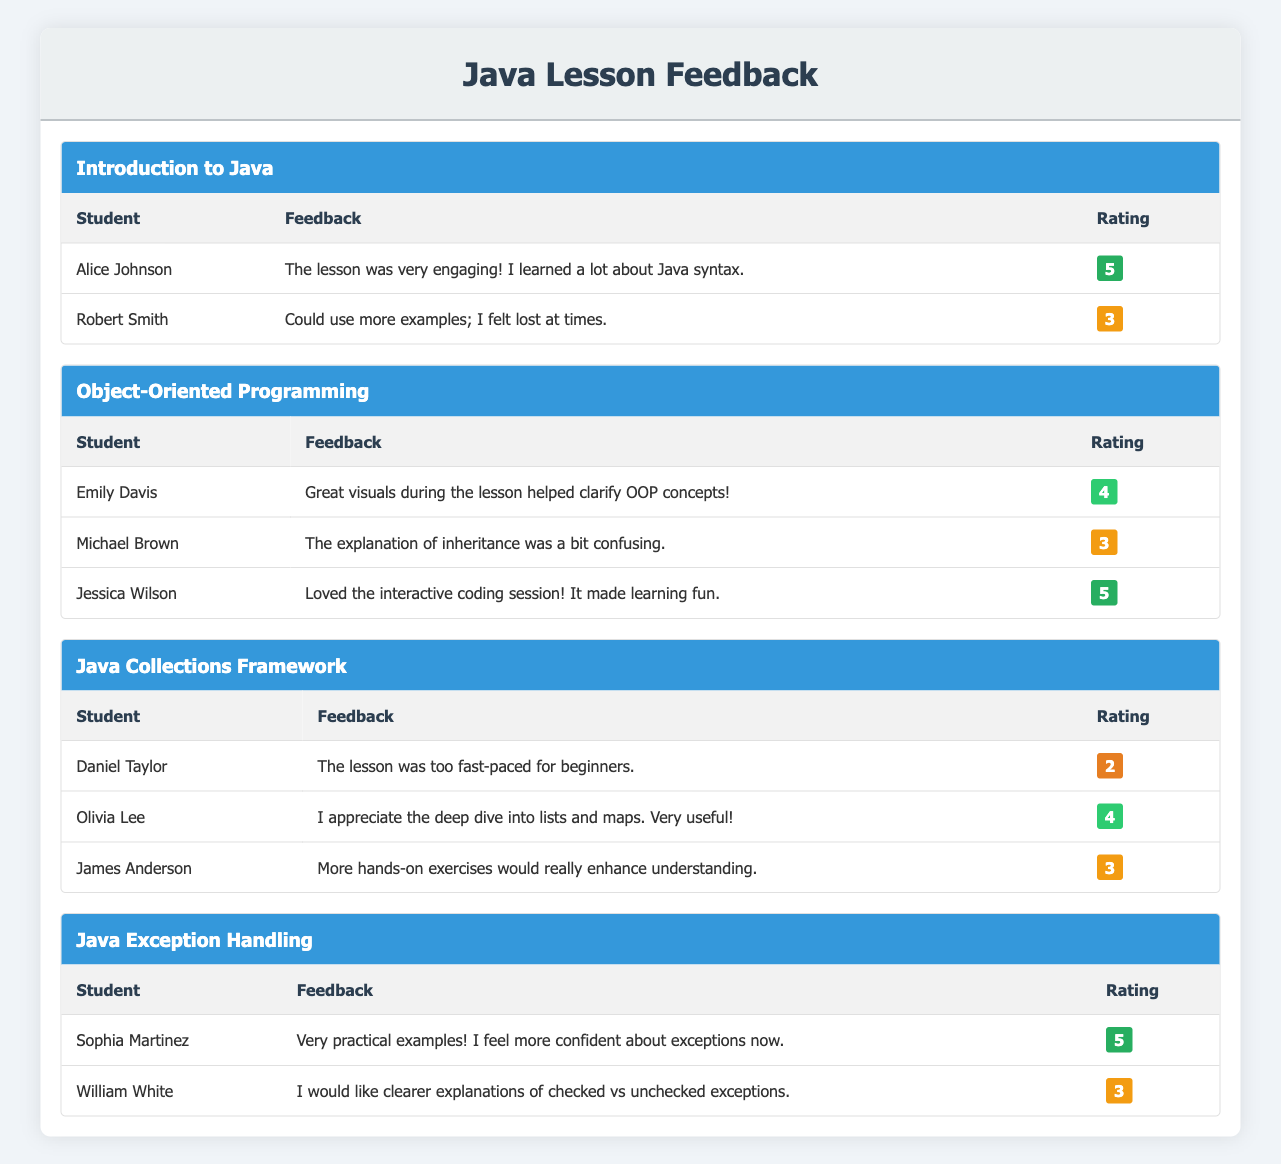What was the highest rating given for the "Java Collections Framework"? The feedback ratings for the "Java Collections Framework" lesson are 2, 4, and 3. The highest rating among these is 4, given by Olivia Lee.
Answer: 4 What feedback did Alice Johnson provide for the "Introduction to Java"? Alice Johnson mentioned that "The lesson was very engaging! I learned a lot about Java syntax." in her feedback.
Answer: The lesson was very engaging! I learned a lot about Java syntax How many students rated the "Object-Oriented Programming" lesson? The "Object-Oriented Programming" lesson received feedback from three students: Emily Davis, Michael Brown, and Jessica Wilson. Therefore, the total number of students who rated this lesson is three.
Answer: 3 Is it true that every student rated the "Java Exception Handling" lesson with a score of 3 or more? For the "Java Exception Handling" lesson, Sophia Martinez rated it as 5, and William White rated it as 3. Therefore, both ratings are 3 or higher, making the statement true.
Answer: Yes What is the average rating given for the "Java Collections Framework"? The ratings for the "Java Collections Framework" are 2, 4, and 3. To find the average, we sum these ratings: 2 + 4 + 3 = 9. Then we divide by the number of ratings (3): 9 / 3 = 3. Therefore, the average rating is 3.
Answer: 3 Which lesson had the most positive feedback based on ratings? To determine which lesson had the most positive feedback, we can look at the highest ratings given for each lesson: "Introduction to Java" (5, 3), "Object-Oriented Programming" (4, 3, 5), "Java Collections Framework" (2, 4, 3), and "Java Exception Handling" (5, 3). The "Object-Oriented Programming" lesson has the highest rating of 5, given by Jessica Wilson.
Answer: Object-Oriented Programming How many feedback entries in total were provided for the "Java Exception Handling" lesson? The "Java Exception Handling" lesson received feedback from two students, Sophia Martinez and William White. Thus, there are two feedback entries in total for this lesson.
Answer: 2 What student gave the least favorable feedback for the "Java Collections Framework"? The least favorable feedback for the "Java Collections Framework" was given by Daniel Taylor, who rated the lesson 2 and commented that "The lesson was too fast-paced for beginners."
Answer: Daniel Taylor How many unique ratings were given across all lessons? The ratings given were 2, 3, 4, and 5. Since these are the only scores provided, we can conclude that there are four unique ratings across all lessons.
Answer: 4 Did any student find the "Object-Oriented Programming" lesson more engaging than the "Java Collections Framework"? Jessica Wilson rated the "Object-Oriented Programming" lesson with a score of 5, while the highest rating for the "Java Collections Framework" was 4, given by Olivia Lee. This indicates that Jessica found the lesson more engaging than the better-rated feedback in the latter.
Answer: Yes 